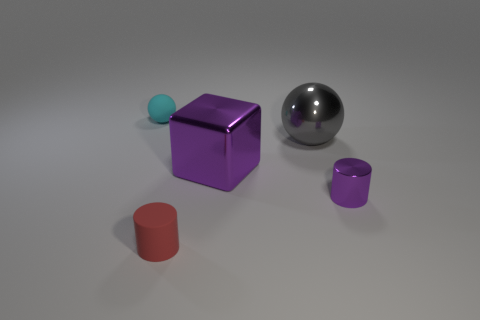Add 3 small things. How many objects exist? 8 Subtract all cubes. How many objects are left? 4 Subtract 0 cyan cubes. How many objects are left? 5 Subtract all tiny brown blocks. Subtract all small balls. How many objects are left? 4 Add 2 tiny purple cylinders. How many tiny purple cylinders are left? 3 Add 1 cyan objects. How many cyan objects exist? 2 